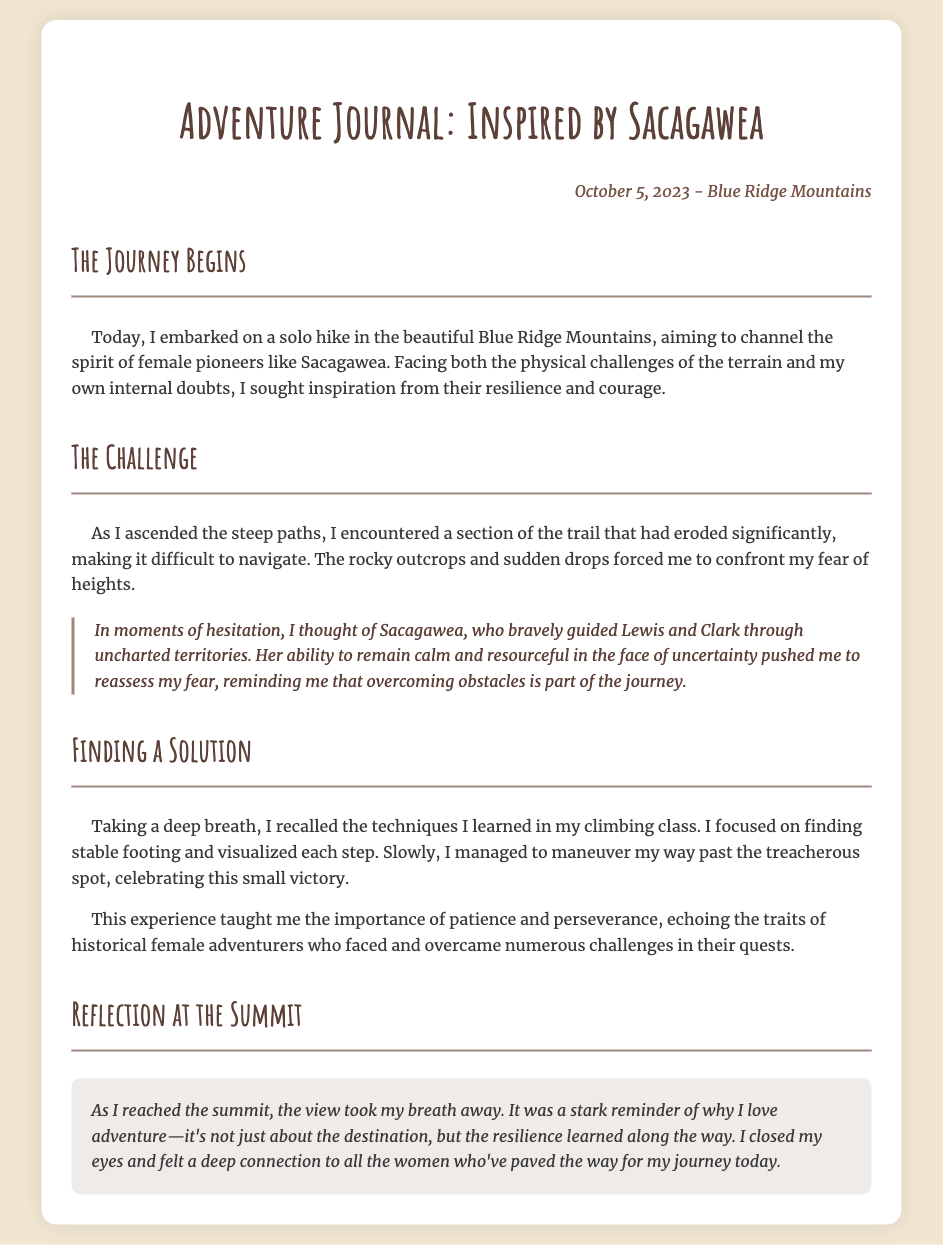What is the date of the journal entry? The date of the journal entry is mentioned at the top of the document under the location.
Answer: October 5, 2023 Where did the adventure take place? The location of the adventure is specified in the date-location section of the journal.
Answer: Blue Ridge Mountains Who is the historical figure that inspired the writer? The inspiration for the writer, mentioned multiple times in the journal, indicates the influential figure's name.
Answer: Sacagawea What is the main challenge faced during the hike? The challenge is identified as a specific condition on the trail discussed in the section titled "The Challenge."
Answer: Eroded trail What lesson did the writer learn from the experience? The conclusion highlights the key takeaway the writer had during the adventure, found in the reflection section.
Answer: Importance of patience and perseverance What emotion does the writer express upon reaching the summit? The reflection at the summit discusses the feelings experienced by the writer at that moment, particularly the realization noted.
Answer: Deep connection What technique helped the writer navigate the difficult section? The writer mentions techniques learned in a climbing class, which helped overcome the challenge described.
Answer: Stable footing What is the purpose of this adventure journal? The overall aim of the journal is discussed at the beginning where the writer reflects on the motivation behind her journey.
Answer: To channel the spirit of female pioneers 